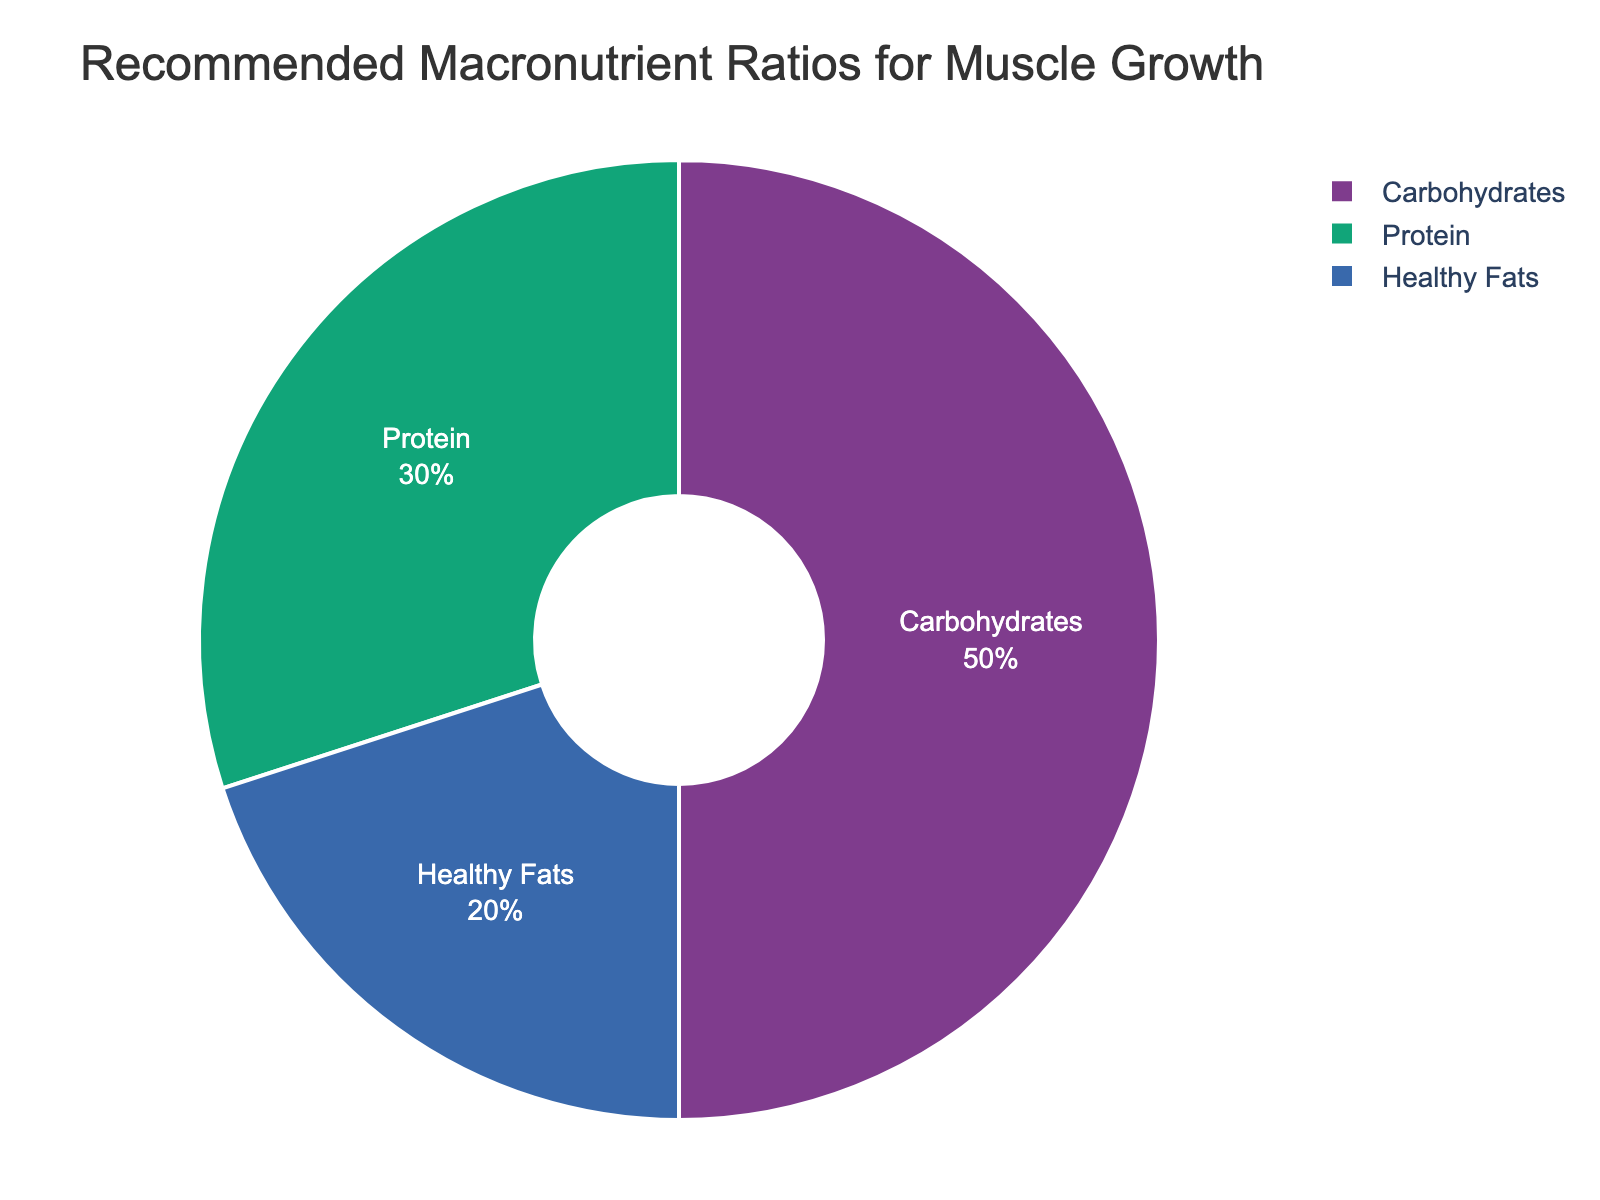What percentage of the recommended macronutrient intake is dedicated to protein? The pie chart shows that the protein segment makes up 30% of the total intake.
Answer: 30% What portion of the recommended intake is made up by carbohydrates and healthy fats combined? Adding the percentages for carbohydrates (50%) and healthy fats (20%), we get 50% + 20% = 70%.
Answer: 70% How does the percentage of carbohydrates compare to the percentage of protein? The pie chart shows that carbohydrates make up 50% of the recommended intake while protein makes up 30%. 50% is greater than 30%, indicating that carbohydrates are recommended in a higher proportion than protein.
Answer: Carbohydrates > Protein What is the visual appearance of the protein segment on the pie chart? The protein segment is represented as a pie slice that takes up 30% of the pie chart, labeled clearly, and colored with one of the bold colors from the palette. The text is inside the slice, indicating 30%.
Answer: 30% of the pie chart Which macronutrient has the smallest recommended percentage, and by what margin does it differ from the next smallest segment? The smallest segment is healthy fats at 20%. The next smallest segment is protein at 30%, so the difference is 30% - 20% = 10%.
Answer: Healthy Fats, 10% What's the overall contribution of protein and healthy fats to the total recommended intake, and what fraction does it represent? Adding the percentages for protein (30%) and healthy fats (20%), we get 30% + 20% = 50%. This means that protein and healthy fats together make up half of the total recommended intake.
Answer: 50%, 1/2 Compare the combined percentage of carbohydrates and protein to that of healthy fats. Adding carbohydrates (50%) and protein (30%), we get 80%. Healthy fats alone are 20%. Clearly, the combined percentage of carbohydrates and protein (80%) is significantly higher than that of healthy fats.
Answer: Carbohydrates + Protein > Healthy Fats Which macronutrient has the largest share, and what fraction of the pie chart does it occupy? The largest share is carbohydrates with 50%, which tentatively represents half of the total pie chart.
Answer: Carbohydrates, 1/2 